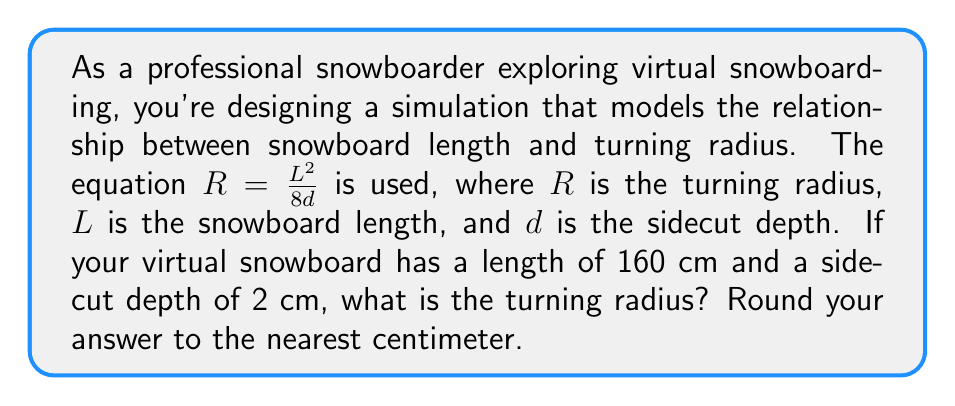Could you help me with this problem? To solve this problem, we'll use the given equation and substitute the known values:

1) The equation: $R = \frac{L^2}{8d}$

2) Given values:
   $L = 160$ cm (snowboard length)
   $d = 2$ cm (sidecut depth)

3) Substitute these values into the equation:
   $R = \frac{(160\text{ cm})^2}{8(2\text{ cm})}$

4) Simplify:
   $R = \frac{25,600\text{ cm}^2}{16\text{ cm}}$

5) Perform the division:
   $R = 1,600\text{ cm}$

6) Round to the nearest centimeter:
   $R = 1,600\text{ cm}$

This result means that with a 160 cm snowboard and a 2 cm sidecut depth, the turning radius in the virtual snowboarding simulation would be 1,600 cm or 16 meters.
Answer: 1,600 cm 